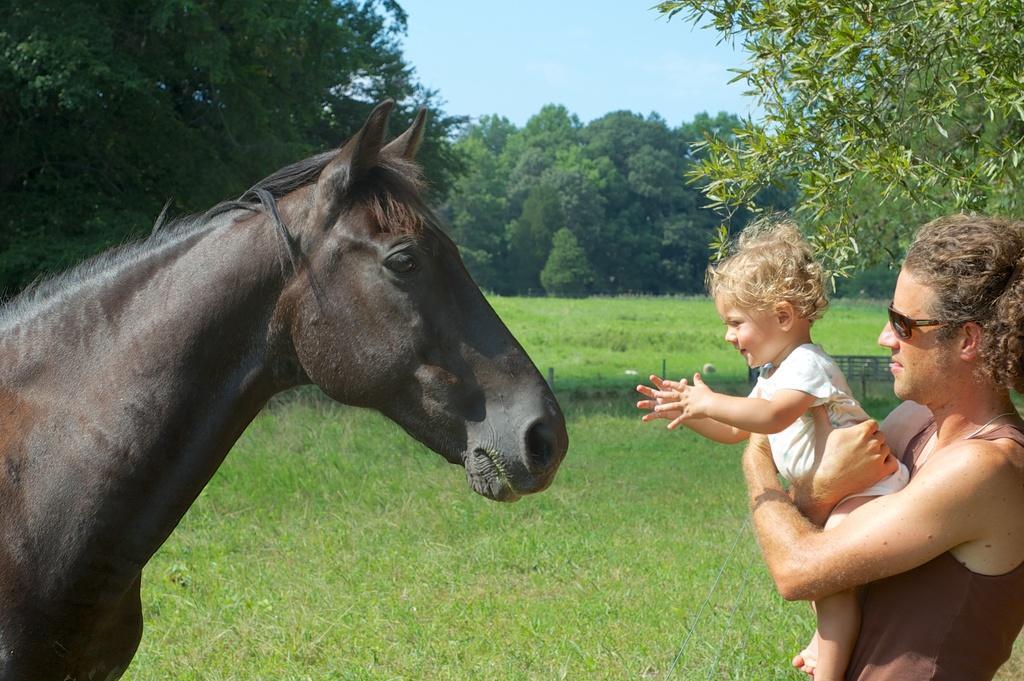Can you describe this image briefly? In this picture we can see a horse, a man and a kid. The kid is trying to touch the horse, in the background we can see couple of trees and grass. 